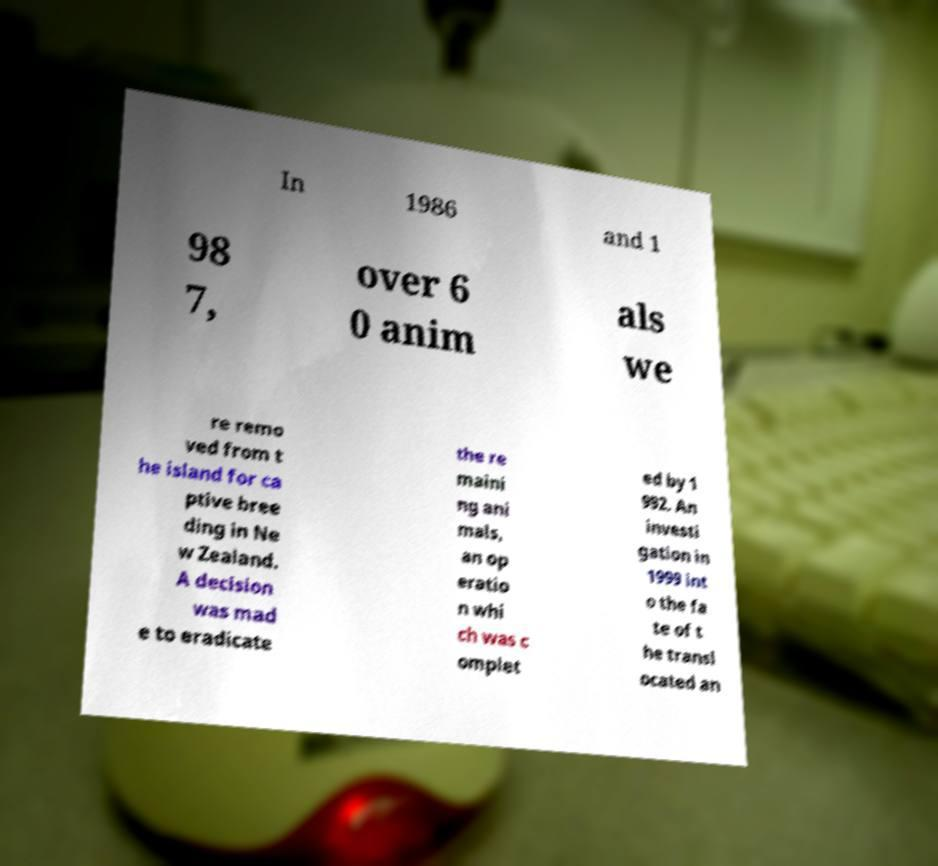For documentation purposes, I need the text within this image transcribed. Could you provide that? In 1986 and 1 98 7, over 6 0 anim als we re remo ved from t he island for ca ptive bree ding in Ne w Zealand. A decision was mad e to eradicate the re maini ng ani mals, an op eratio n whi ch was c omplet ed by 1 992. An investi gation in 1999 int o the fa te of t he transl ocated an 